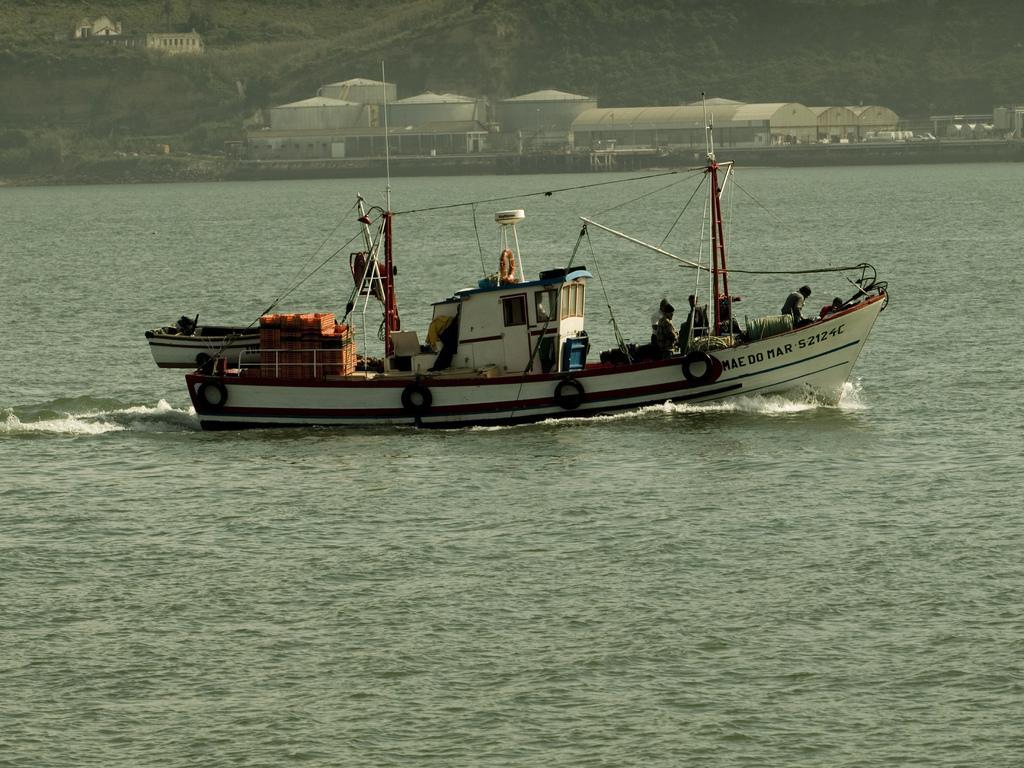Please provide a concise description of this image. In this image, we can see few people are sailing a boat on the water. Here we can see another boat. Top of the image, we can see containers, sheds, trees, plants and building. 